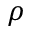Convert formula to latex. <formula><loc_0><loc_0><loc_500><loc_500>\rho</formula> 